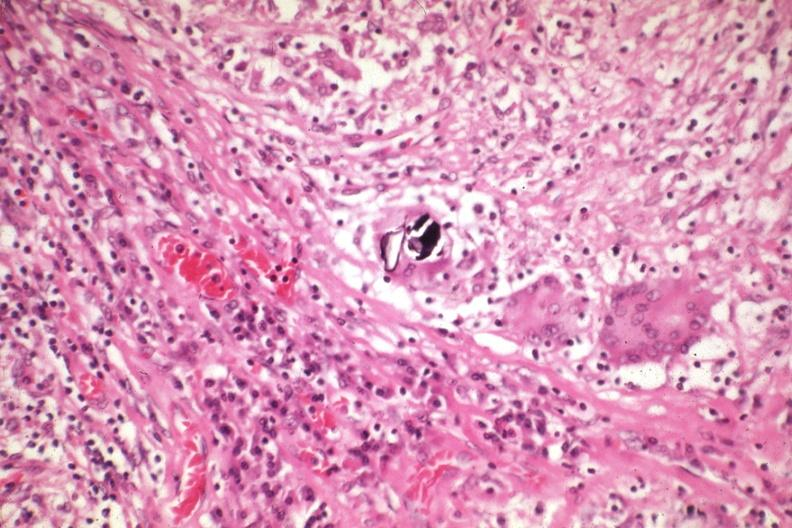what is present?
Answer the question using a single word or phrase. Sarcoidosis 